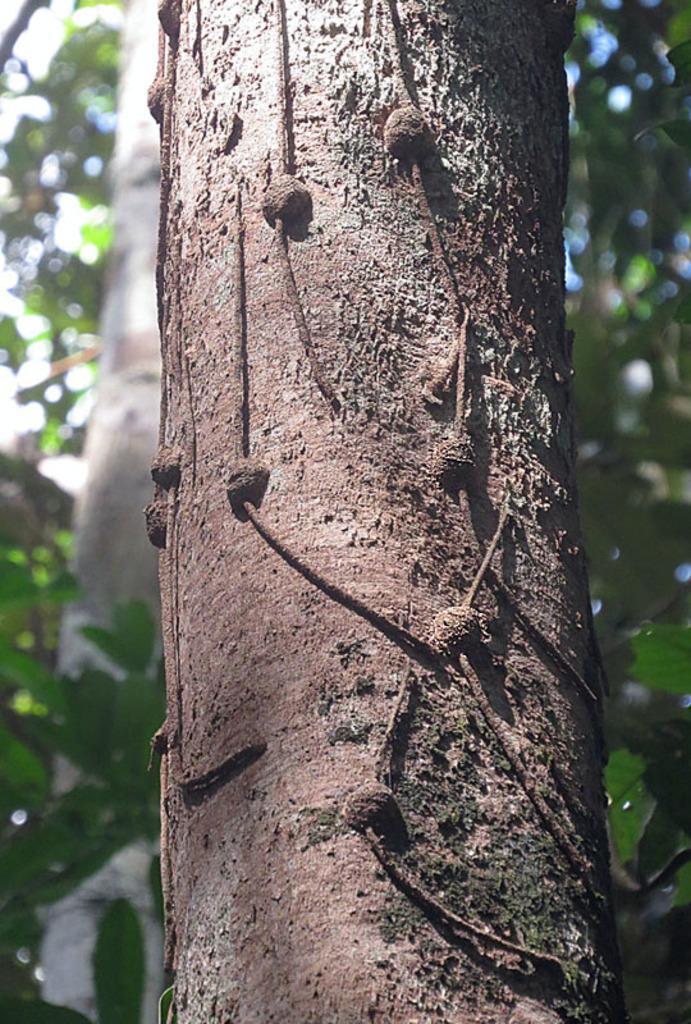Please provide a concise description of this image. In this image there is a tree trunk, at the background of the image there are trees. 